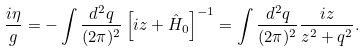Convert formula to latex. <formula><loc_0><loc_0><loc_500><loc_500>\frac { i \eta } { g } = - \int \frac { d ^ { 2 } q } { ( 2 \pi ) ^ { 2 } } \left [ i z + \hat { H } _ { 0 } \right ] ^ { - 1 } = \int \frac { d ^ { 2 } q } { ( 2 \pi ) ^ { 2 } } \frac { i z } { z ^ { 2 } + q ^ { 2 } } .</formula> 